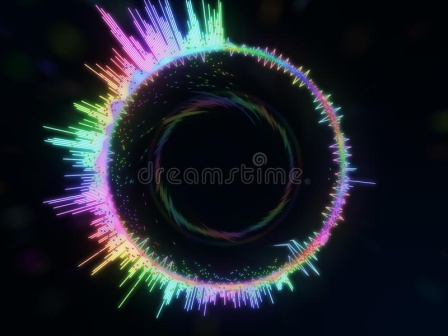Describe the potential scientific implications of such a cosmic phenomenon. This image represents a stylized visualization of a black hole surrounded by an accretion disk composed of various high-energy emissions. In reality, black holes are regions of space where gravitational forces are so strong that nothing, not even light, can escape. The vibrant colors and swirling patterns could symbolize the intense energetic interactions occurring near the event horizon. Scientific implications of studying these phenomena include understanding the fundamental laws of physics, exploring the nature of gravity, and gaining insights into the behavior of matter and energy under extreme conditions. This knowledge can improve our comprehension of the universe's formation, the life cycle of stars, and the potential for black holes to influence galaxy formation and evolution. Can you explain how artists might be inspired by such cosmic imagery? Artists often draw inspiration from the mysteries and vast beauty of the cosmos, much like the one depicted in this image. The swirling colors and ethereal patterns can evoke a sense of wonder and curiosity, inspiring artists to create works that explore themes of infinity, the unknown, and the sublime. Such imagery can lead to the creation of abstract art that emphasizes color, movement, and light, or even more figurative works that depict imagined cosmic landscapes. Moreover, the concept of black holes and the interplay of light and dark can be powerful metaphors for themes such as creation, destruction, and the passage of time, providing rich material for artistic exploration. 